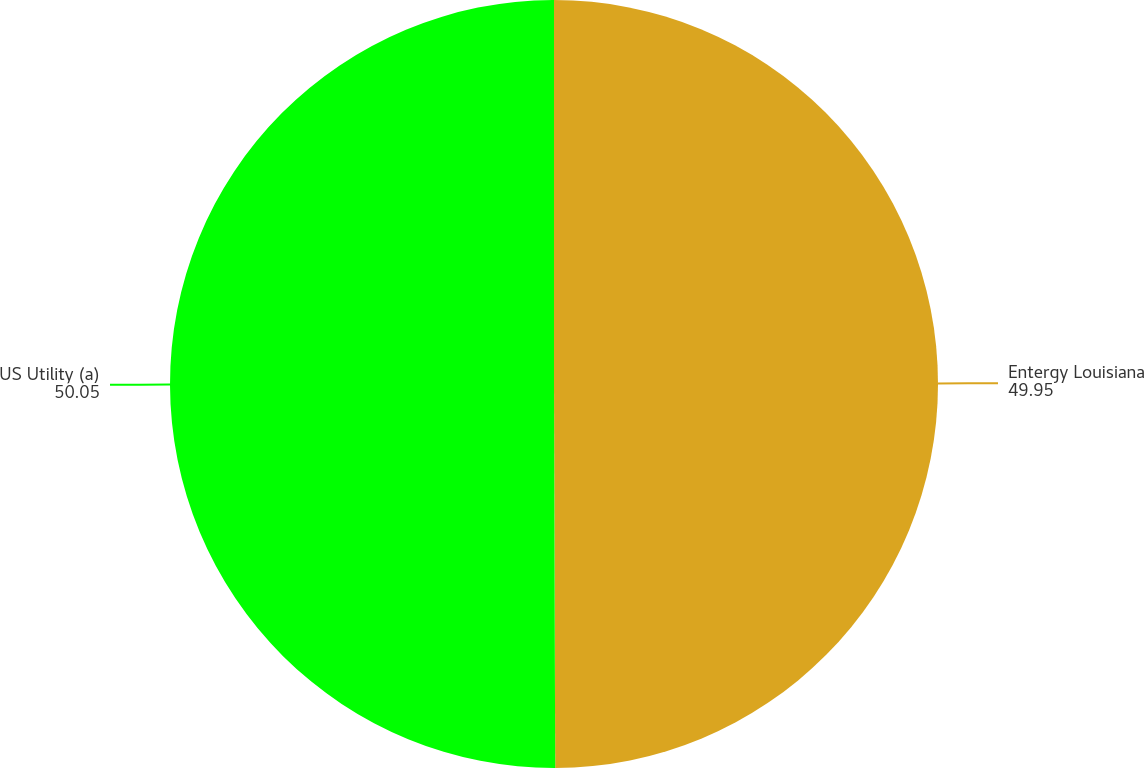Convert chart to OTSL. <chart><loc_0><loc_0><loc_500><loc_500><pie_chart><fcel>Entergy Louisiana<fcel>US Utility (a)<nl><fcel>49.95%<fcel>50.05%<nl></chart> 